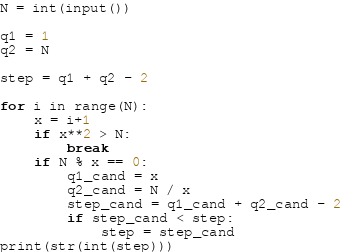<code> <loc_0><loc_0><loc_500><loc_500><_Python_>N = int(input())

q1 = 1
q2 = N

step = q1 + q2 - 2

for i in range(N):
    x = i+1
    if x**2 > N:
        break
    if N % x == 0:
        q1_cand = x
        q2_cand = N / x
        step_cand = q1_cand + q2_cand - 2
        if step_cand < step:
            step = step_cand
print(str(int(step)))</code> 